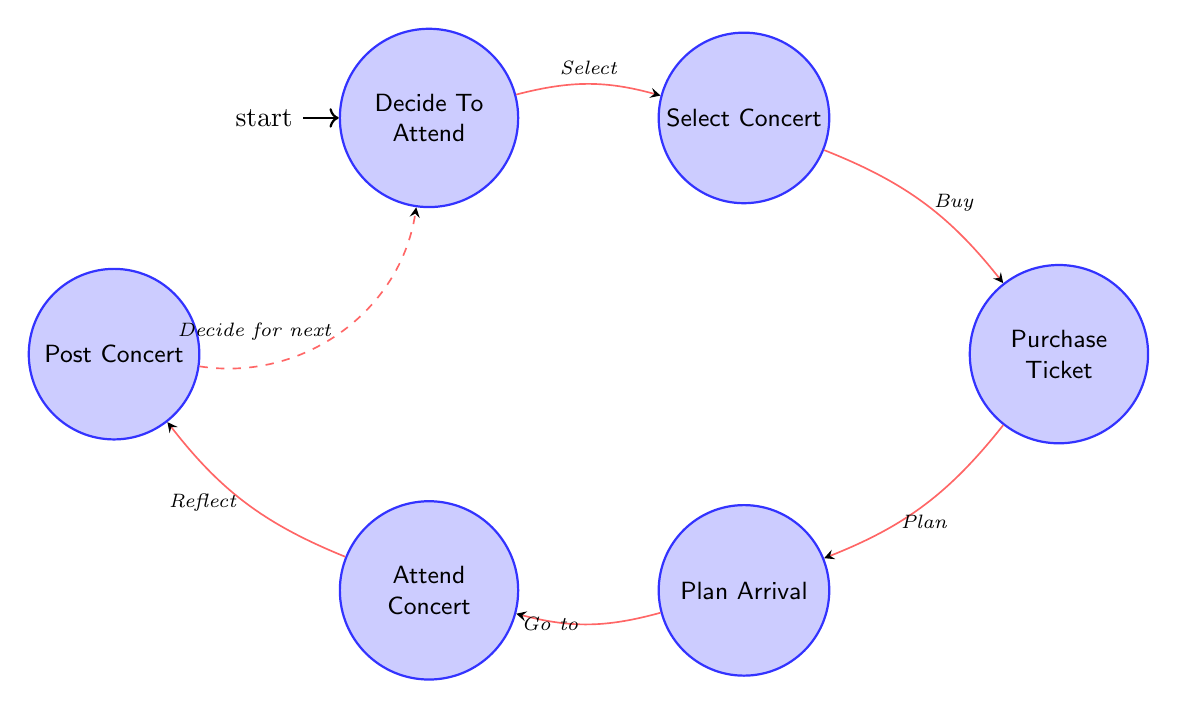What is the first state in the diagram? The first state is the initial node labeled "Decide To Attend," which indicates the starting point of the process for attending a concert.
Answer: Decide To Attend How many states are in the diagram? There are a total of six states represented in the diagram, which are: Decide To Attend, Select Concert, Purchase Ticket, Plan Arrival, Attend Concert, and Post Concert.
Answer: Six What transition comes after "Select Concert"? The transition following "Select Concert" is labeled "Buy," indicating the action taken after selecting a concert, which leads to the next state "Purchase Ticket."
Answer: Buy Which state does "Plan Arrival" lead to? "Plan Arrival" transitions to "Attend Concert," meaning that after planning the arrival, the next step is attending the concert.
Answer: Attend Concert How many transitions are depicted in the diagram? The diagram features a total of five transitions. Each transition connects a pair of states, illustrating the sequence of actions from deciding to attend a concert to posting about the concert after attending it.
Answer: Five What is the last state in the process? The last state in the process is "Post Concert," which occurs after attending the concert and involves reflecting on the experience and sharing it with others.
Answer: Post Concert What action is required to go from "Attend Concert" to "Post Concert"? The action required to move from "Attend Concert" to "Post Concert" is "Reflect," emphasizing the need to think back on the concert experience before sharing it.
Answer: Reflect Which state is directly before "Purchase Ticket"? The state directly prior to "Purchase Ticket" is "Select Concert," indicating that selecting a concert precedes purchasing the ticket.
Answer: Select Concert What is the transition description from "Plan Arrival" to "Attend Concert"? The transition description between "Plan Arrival" and "Attend Concert" is "Go to," signifying the movement from planning to attending the concert.
Answer: Go to 